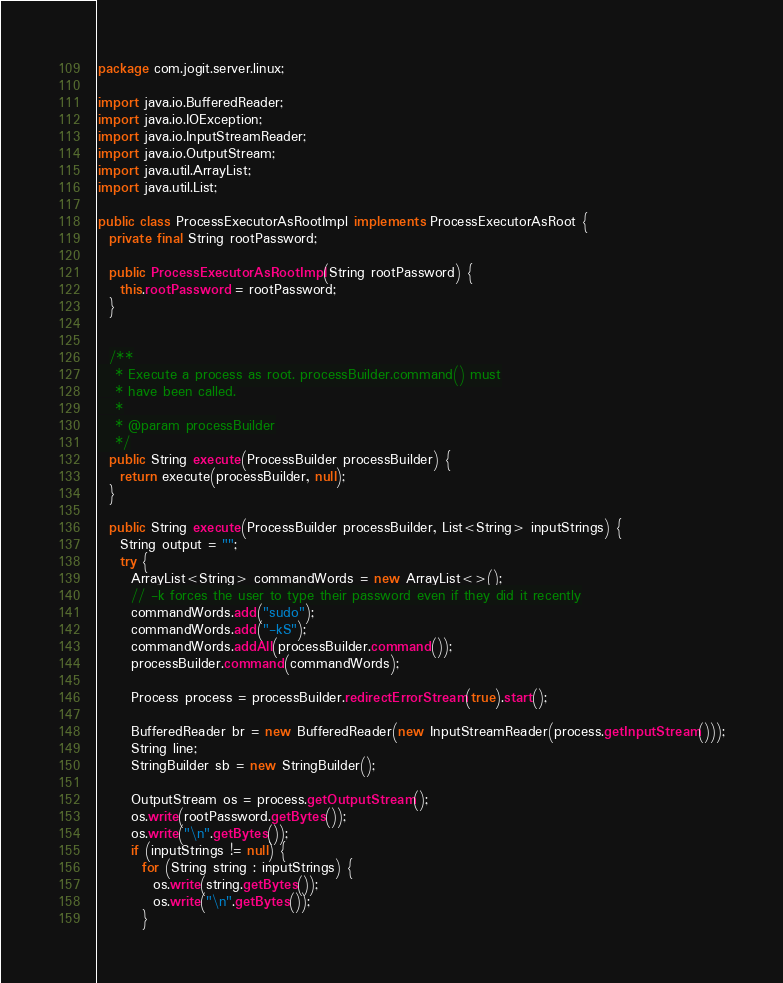<code> <loc_0><loc_0><loc_500><loc_500><_Java_>package com.jogit.server.linux;

import java.io.BufferedReader;
import java.io.IOException;
import java.io.InputStreamReader;
import java.io.OutputStream;
import java.util.ArrayList;
import java.util.List;

public class ProcessExecutorAsRootImpl implements ProcessExecutorAsRoot {
  private final String rootPassword;

  public ProcessExecutorAsRootImpl(String rootPassword) {
    this.rootPassword = rootPassword;
  }


  /**
   * Execute a process as root. processBuilder.command() must
   * have been called.
   *
   * @param processBuilder
   */
  public String execute(ProcessBuilder processBuilder) {
    return execute(processBuilder, null);
  }

  public String execute(ProcessBuilder processBuilder, List<String> inputStrings) {
    String output = "";
    try {
      ArrayList<String> commandWords = new ArrayList<>();
      // -k forces the user to type their password even if they did it recently
      commandWords.add("sudo");
      commandWords.add("-kS");
      commandWords.addAll(processBuilder.command());
      processBuilder.command(commandWords);

      Process process = processBuilder.redirectErrorStream(true).start();

      BufferedReader br = new BufferedReader(new InputStreamReader(process.getInputStream()));
      String line;
      StringBuilder sb = new StringBuilder();

      OutputStream os = process.getOutputStream();
      os.write(rootPassword.getBytes());
      os.write("\n".getBytes());
      if (inputStrings != null) {
        for (String string : inputStrings) {
          os.write(string.getBytes());
          os.write("\n".getBytes());
        }</code> 